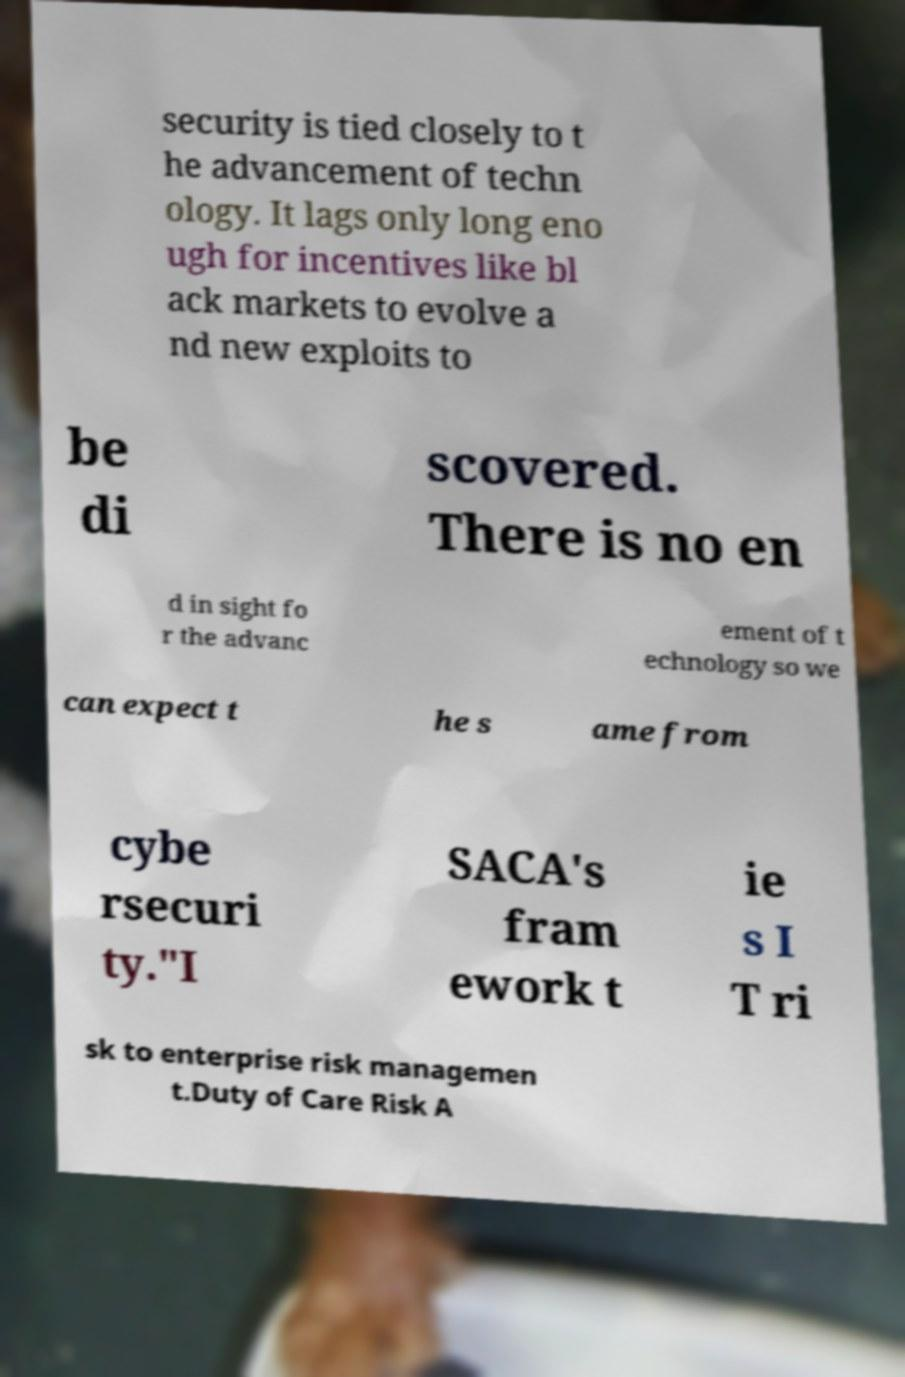Could you extract and type out the text from this image? security is tied closely to t he advancement of techn ology. It lags only long eno ugh for incentives like bl ack markets to evolve a nd new exploits to be di scovered. There is no en d in sight fo r the advanc ement of t echnology so we can expect t he s ame from cybe rsecuri ty."I SACA's fram ework t ie s I T ri sk to enterprise risk managemen t.Duty of Care Risk A 